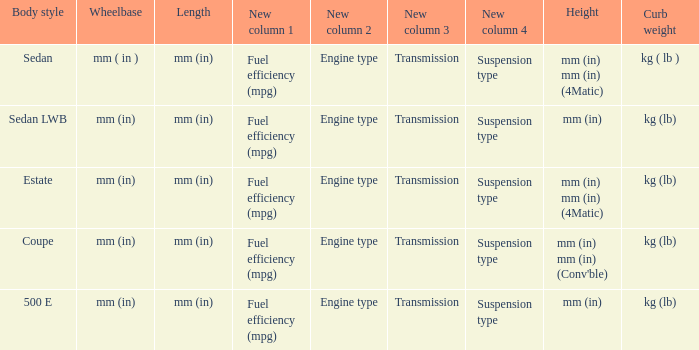What is the curb weight of the model with a wheelbase of mm (in) and elevation of mm (in) mm (in) (4matic)? Kg ( lb ), kg (lb). 